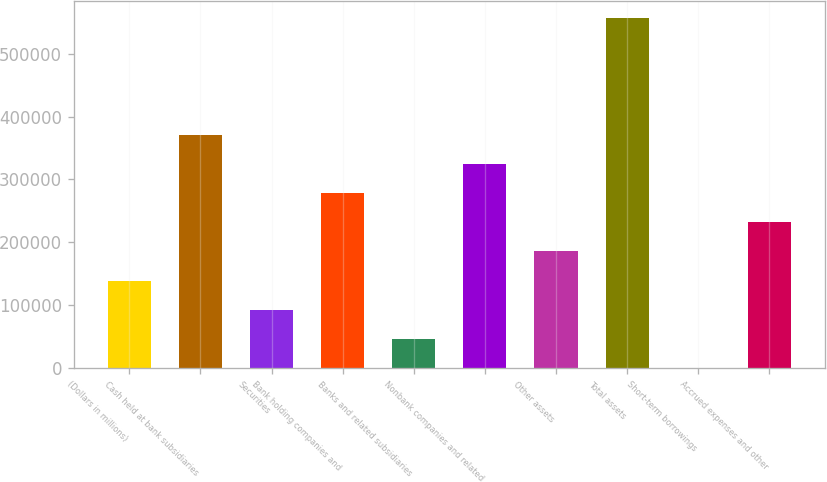Convert chart. <chart><loc_0><loc_0><loc_500><loc_500><bar_chart><fcel>(Dollars in millions)<fcel>Cash held at bank subsidiaries<fcel>Securities<fcel>Bank holding companies and<fcel>Banks and related subsidiaries<fcel>Nonbank companies and related<fcel>Other assets<fcel>Total assets<fcel>Short-term borrowings<fcel>Accrued expenses and other<nl><fcel>139183<fcel>371129<fcel>92793.6<fcel>278351<fcel>46404.3<fcel>324740<fcel>185572<fcel>556687<fcel>15<fcel>231962<nl></chart> 